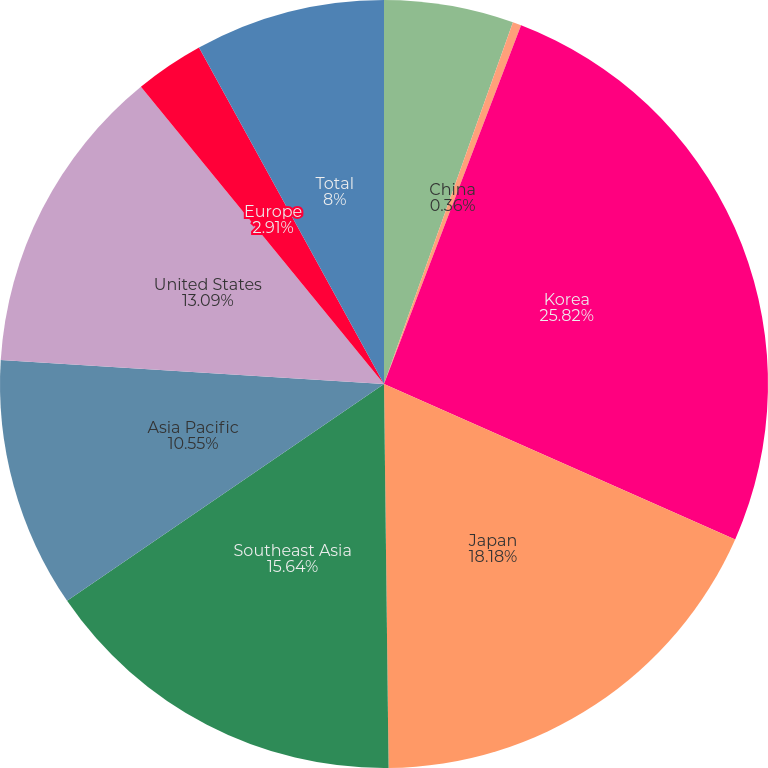Convert chart. <chart><loc_0><loc_0><loc_500><loc_500><pie_chart><fcel>Taiwan<fcel>China<fcel>Korea<fcel>Japan<fcel>Southeast Asia<fcel>Asia Pacific<fcel>United States<fcel>Europe<fcel>Total<nl><fcel>5.45%<fcel>0.36%<fcel>25.82%<fcel>18.18%<fcel>15.64%<fcel>10.55%<fcel>13.09%<fcel>2.91%<fcel>8.0%<nl></chart> 